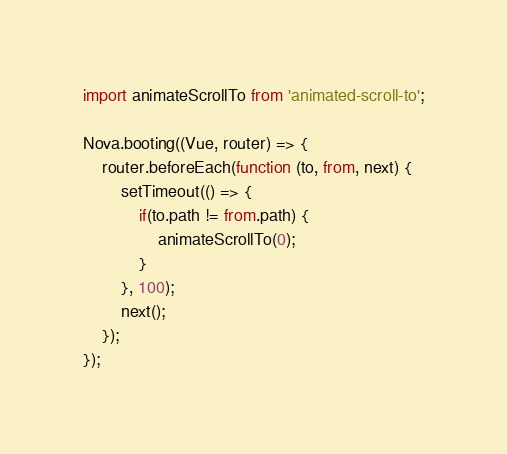Convert code to text. <code><loc_0><loc_0><loc_500><loc_500><_JavaScript_>import animateScrollTo from 'animated-scroll-to';

Nova.booting((Vue, router) => {
    router.beforeEach(function (to, from, next) {
        setTimeout(() => {
            if(to.path != from.path) {
                animateScrollTo(0);
            }
        }, 100);
        next();
    });
});
</code> 